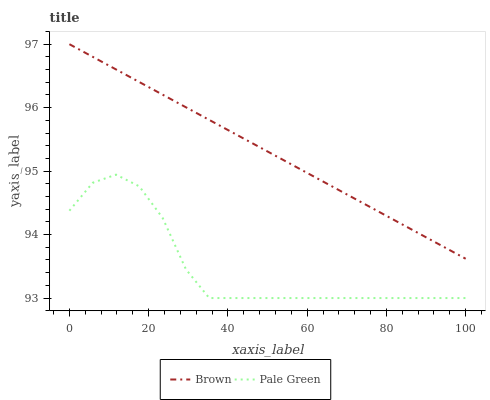Does Pale Green have the minimum area under the curve?
Answer yes or no. Yes. Does Brown have the maximum area under the curve?
Answer yes or no. Yes. Does Pale Green have the maximum area under the curve?
Answer yes or no. No. Is Brown the smoothest?
Answer yes or no. Yes. Is Pale Green the roughest?
Answer yes or no. Yes. Is Pale Green the smoothest?
Answer yes or no. No. Does Pale Green have the lowest value?
Answer yes or no. Yes. Does Brown have the highest value?
Answer yes or no. Yes. Does Pale Green have the highest value?
Answer yes or no. No. Is Pale Green less than Brown?
Answer yes or no. Yes. Is Brown greater than Pale Green?
Answer yes or no. Yes. Does Pale Green intersect Brown?
Answer yes or no. No. 